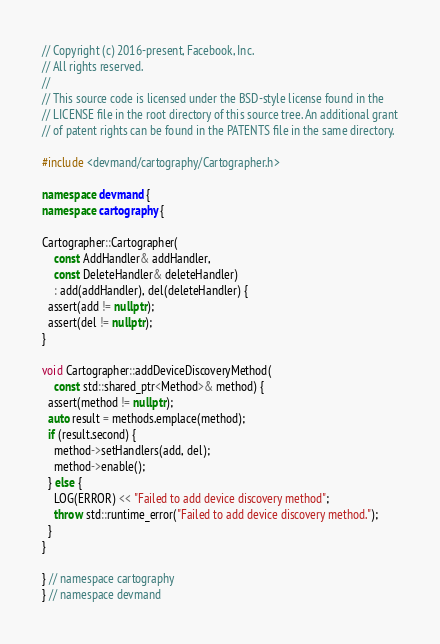Convert code to text. <code><loc_0><loc_0><loc_500><loc_500><_C++_>// Copyright (c) 2016-present, Facebook, Inc.
// All rights reserved.
//
// This source code is licensed under the BSD-style license found in the
// LICENSE file in the root directory of this source tree. An additional grant
// of patent rights can be found in the PATENTS file in the same directory.

#include <devmand/cartography/Cartographer.h>

namespace devmand {
namespace cartography {

Cartographer::Cartographer(
    const AddHandler& addHandler,
    const DeleteHandler& deleteHandler)
    : add(addHandler), del(deleteHandler) {
  assert(add != nullptr);
  assert(del != nullptr);
}

void Cartographer::addDeviceDiscoveryMethod(
    const std::shared_ptr<Method>& method) {
  assert(method != nullptr);
  auto result = methods.emplace(method);
  if (result.second) {
    method->setHandlers(add, del);
    method->enable();
  } else {
    LOG(ERROR) << "Failed to add device discovery method";
    throw std::runtime_error("Failed to add device discovery method.");
  }
}

} // namespace cartography
} // namespace devmand
</code> 